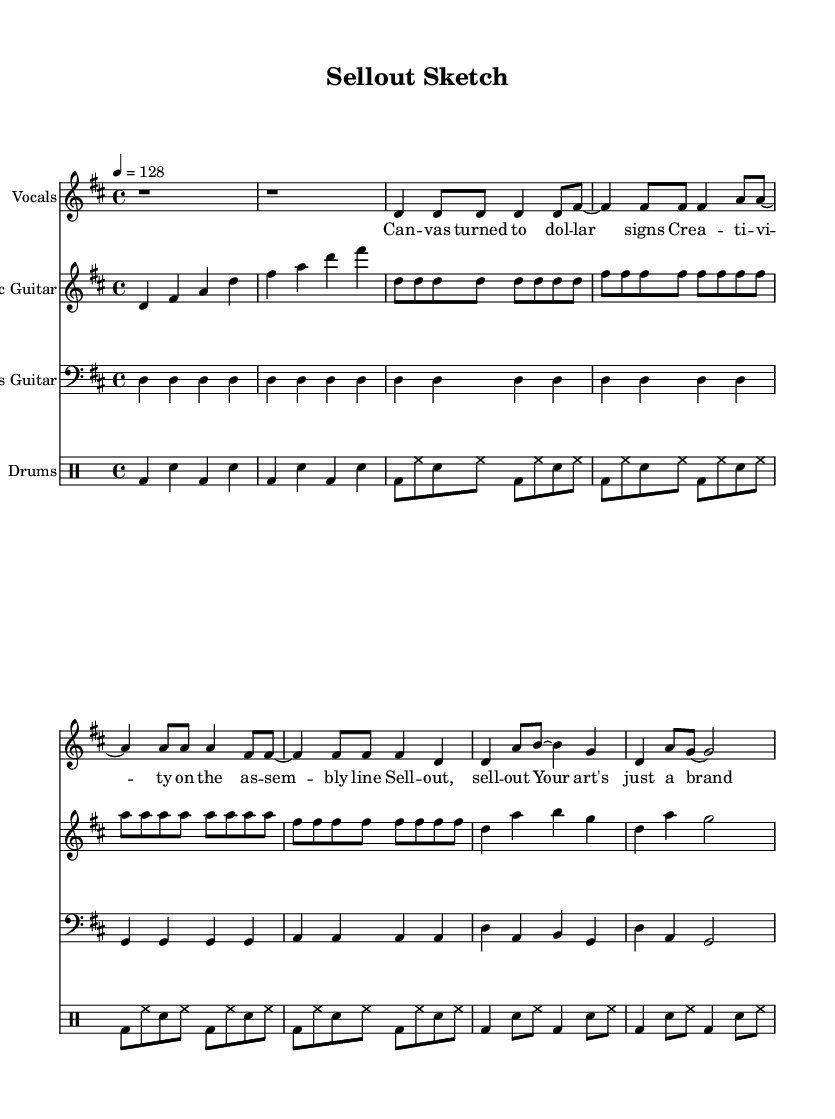What is the key signature of this music? The key signature appears at the beginning of the sheet music. In this case, there are two sharps shown, which indicates D major.
Answer: D major What is the time signature of this piece? The time signature is found at the beginning, indicated by two numbers stacked on top of each other. Here, it shows 4 over 4, meaning there are four beats in a measure and each quarter note receives one beat.
Answer: 4/4 What is the tempo marking for this song? The tempo marking is located above the staff, marked "4 = 128," which indicates that a quarter note should be played at a speed of 128 beats per minute.
Answer: 128 What instruments are included in this score? The score lists multiple instruments at the beginning of each staff. They include Electric Guitar, Bass Guitar, Drums, and Vocals.
Answer: Electric Guitar, Bass Guitar, Drums, Vocals How many measures are in the electric guitar part? To determine the number of measures for the electric guitar, count the number of vertical lines (bar lines) included in the staff. There are eight measures visible.
Answer: 8 What is the vocal line's first lyric? The first lyric can be identified by looking at the text aligned beneath the first note of the vocal part. The first lyric is "Can".
Answer: Can What does the lyric "Sell out, sell out" indicate about the song's theme? This lyric suggests a critique of commercialization in art and creativity, embodying the central theme of artists losing their original intentions for financial gain. It implies a negative connotation associated with corporate influence over personal expression.
Answer: Critique of commercialization 